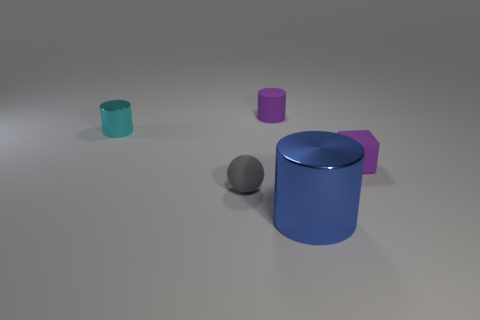Add 4 tiny yellow metal cubes. How many objects exist? 9 Subtract all purple cylinders. How many cylinders are left? 2 Subtract all small matte cylinders. How many cylinders are left? 2 Add 4 small purple cubes. How many small purple cubes exist? 5 Subtract 1 blue cylinders. How many objects are left? 4 Subtract all cylinders. How many objects are left? 2 Subtract 2 cylinders. How many cylinders are left? 1 Subtract all gray cylinders. Subtract all cyan cubes. How many cylinders are left? 3 Subtract all blue spheres. How many purple cylinders are left? 1 Subtract all cyan metallic cylinders. Subtract all gray spheres. How many objects are left? 3 